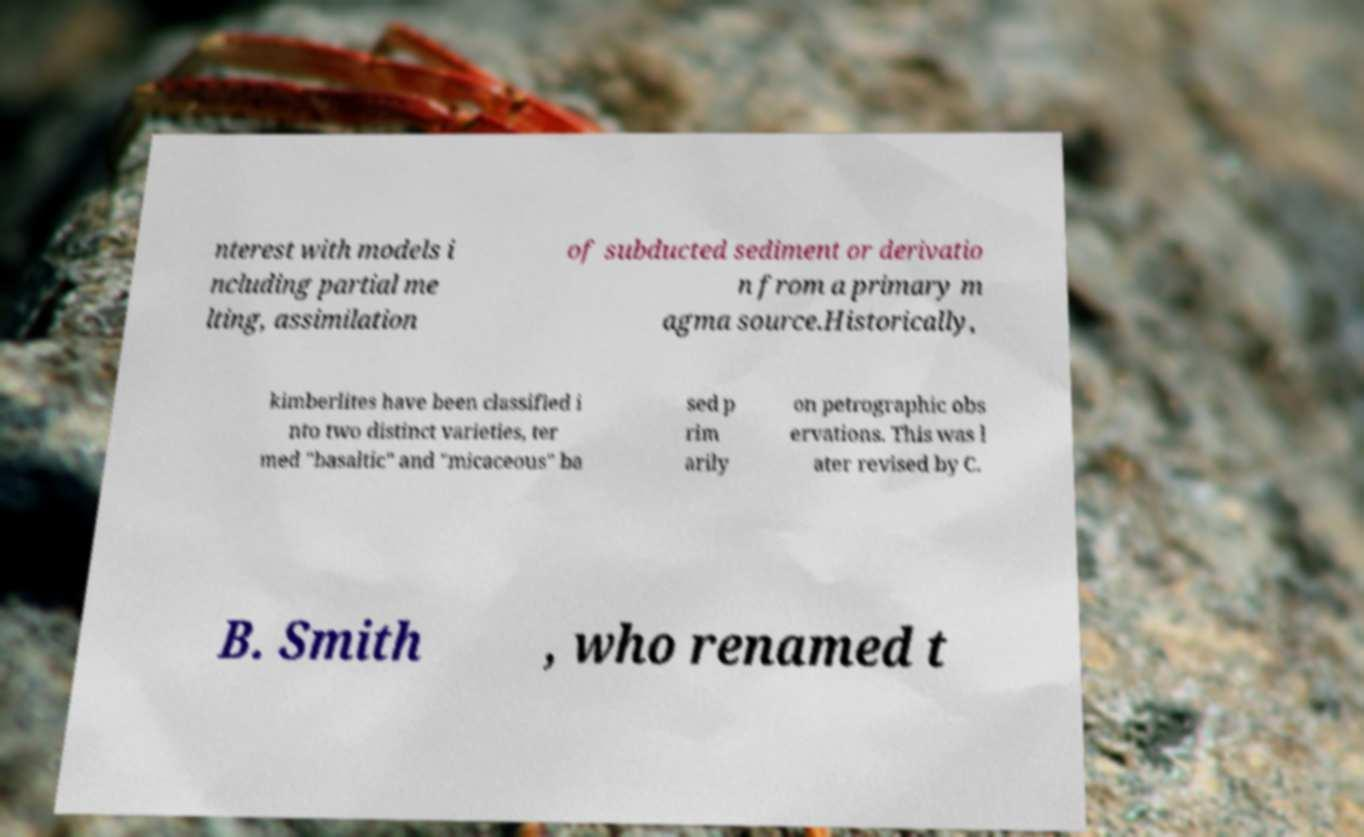Can you read and provide the text displayed in the image?This photo seems to have some interesting text. Can you extract and type it out for me? nterest with models i ncluding partial me lting, assimilation of subducted sediment or derivatio n from a primary m agma source.Historically, kimberlites have been classified i nto two distinct varieties, ter med "basaltic" and "micaceous" ba sed p rim arily on petrographic obs ervations. This was l ater revised by C. B. Smith , who renamed t 